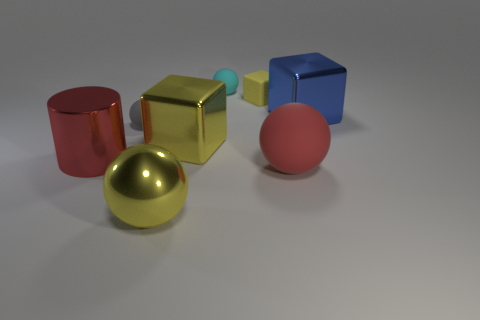Subtract 1 spheres. How many spheres are left? 3 Subtract all blue cylinders. Subtract all purple spheres. How many cylinders are left? 1 Add 1 cylinders. How many objects exist? 9 Subtract all blocks. How many objects are left? 5 Subtract all shiny blocks. Subtract all metal cylinders. How many objects are left? 5 Add 6 yellow shiny spheres. How many yellow shiny spheres are left? 7 Add 1 large red cylinders. How many large red cylinders exist? 2 Subtract 0 purple blocks. How many objects are left? 8 